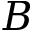Convert formula to latex. <formula><loc_0><loc_0><loc_500><loc_500>B</formula> 